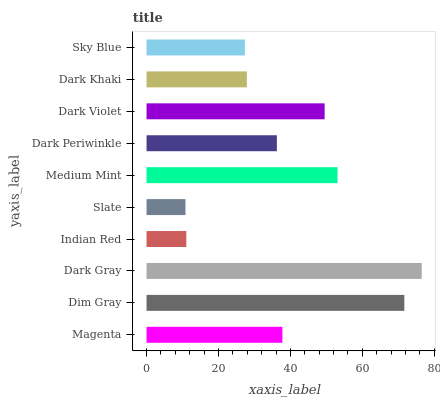Is Slate the minimum?
Answer yes or no. Yes. Is Dark Gray the maximum?
Answer yes or no. Yes. Is Dim Gray the minimum?
Answer yes or no. No. Is Dim Gray the maximum?
Answer yes or no. No. Is Dim Gray greater than Magenta?
Answer yes or no. Yes. Is Magenta less than Dim Gray?
Answer yes or no. Yes. Is Magenta greater than Dim Gray?
Answer yes or no. No. Is Dim Gray less than Magenta?
Answer yes or no. No. Is Magenta the high median?
Answer yes or no. Yes. Is Dark Periwinkle the low median?
Answer yes or no. Yes. Is Dark Khaki the high median?
Answer yes or no. No. Is Dim Gray the low median?
Answer yes or no. No. 